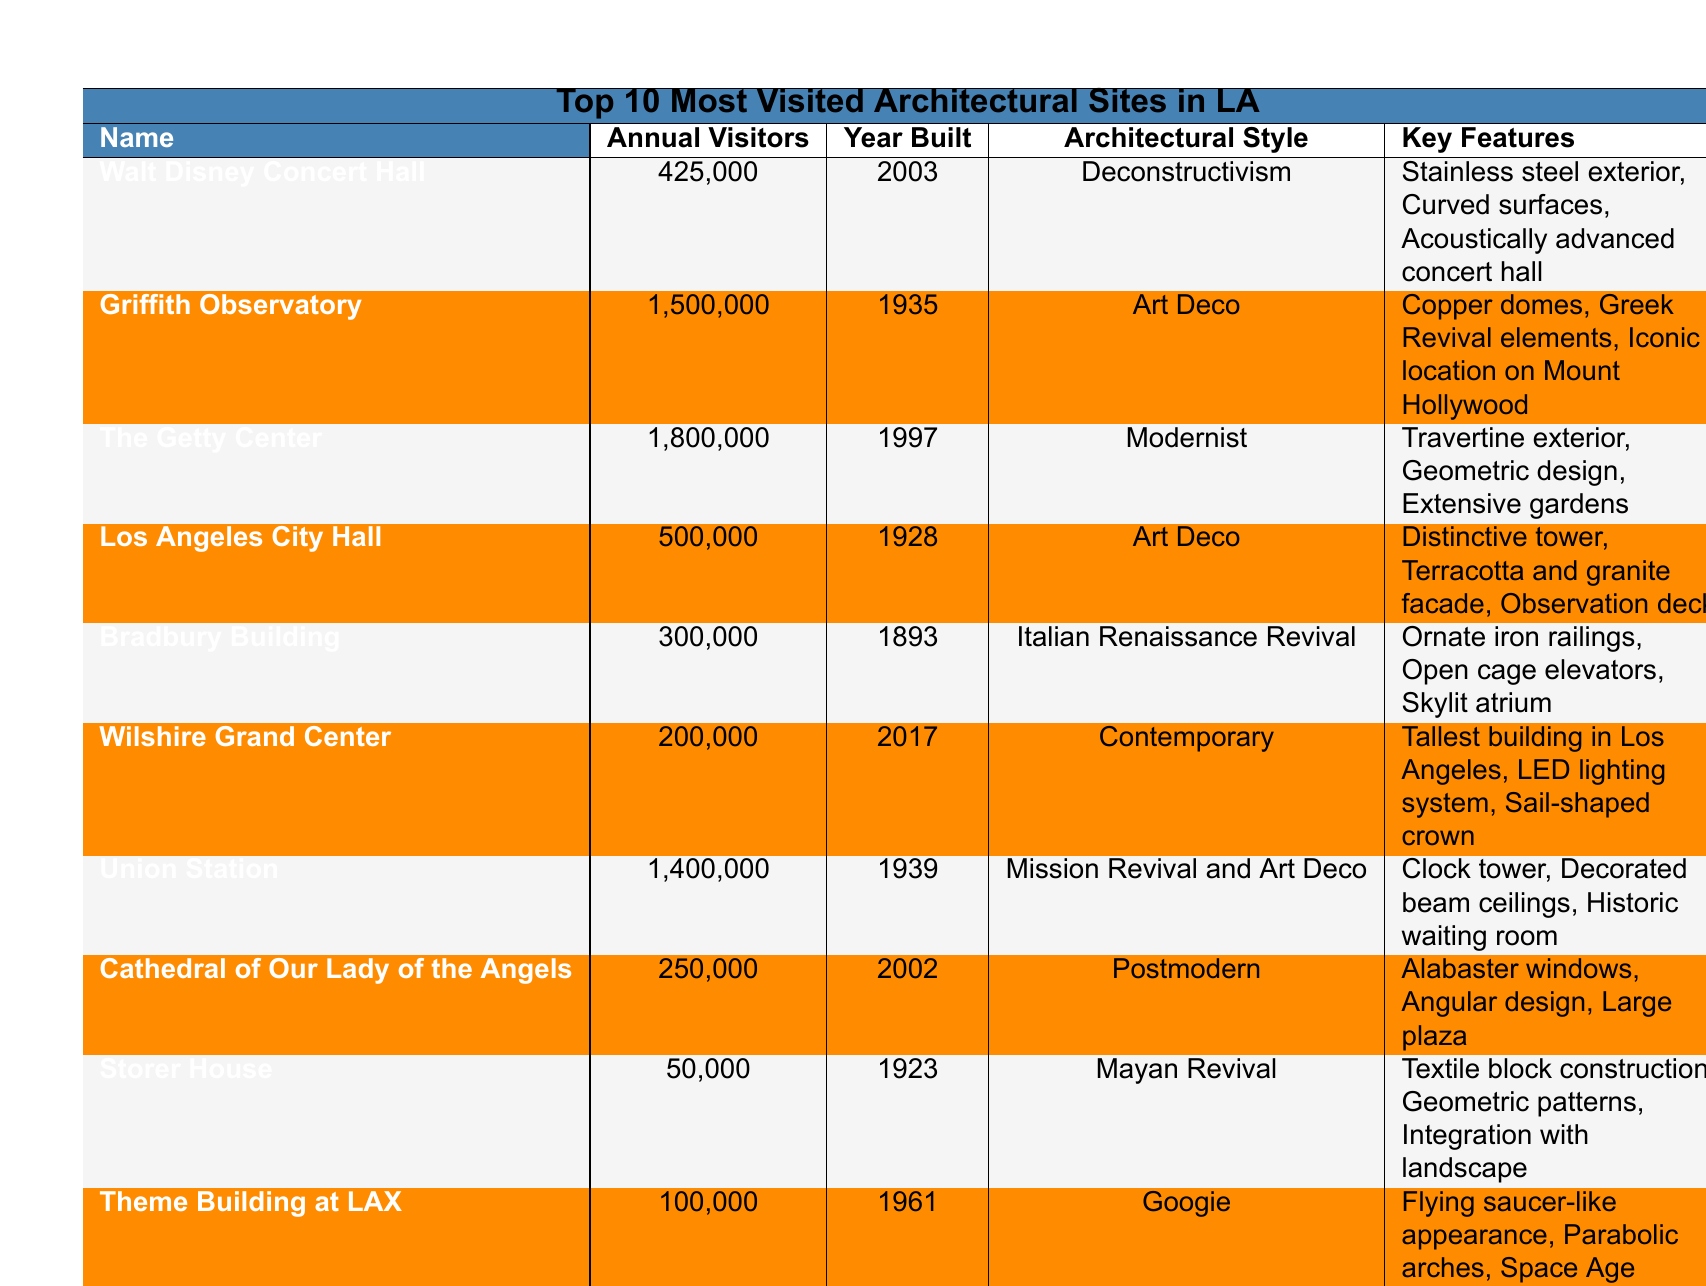What is the architectural style of the Griffith Observatory? The architectural style for the Griffith Observatory is listed in the table as Art Deco.
Answer: Art Deco Which site has the highest annual visitor count? Looking at the annual visitor counts, The Getty Center has the highest number with 1,800,000 visitors.
Answer: The Getty Center How many visitors does the Walt Disney Concert Hall attract annually? The annual visitor count for the Walt Disney Concert Hall is provided in the table as 425,000.
Answer: 425,000 What year was the Los Angeles City Hall built? The table indicates that the Los Angeles City Hall was built in the year 1928.
Answer: 1928 Which architectural styles are featured in the Wilshire Grand Center and the Cathedral of Our Lady of the Angels? The Wilshire Grand Center is classified as Contemporary, while the Cathedral of Our Lady of the Angels is Postmodern.
Answer: Contemporary and Postmodern Is the Storer House more or less visited than the Bradbury Building? The Storer House has 50,000 visitors, while the Bradbury Building has 300,000 visitors, so it is less visited.
Answer: Less visited What are the key features of the Union Station? The table lists the key features of Union Station as a clock tower, decorated beam ceilings, and a historic waiting room.
Answer: Clock tower, decorated beam ceilings, historic waiting room Which sites were built before 1950, and how many of them had over 1 million visitors? The sites built before 1950 are Griffith Observatory, Los Angeles City Hall, Bradbury Building, and Union Station. Out of these, 2 sites, Griffith Observatory (1,500,000) and Union Station (1,400,000), had over 1 million visitors.
Answer: 2 sites Calculate the average annual visitors for the top 3 most visited sites. The visitor counts for the top 3 sites are 1,800,000 (The Getty Center), 1,500,000 (Griffith Observatory), and 1,400,000 (Union Station). Summing these gives 1,800,000 + 1,500,000 + 1,400,000 = 4,700,000. There are 3 sites, so the average is 4,700,000 / 3 = 1,566,667.
Answer: 1,566,667 How does the architectural style of the Theme Building at LAX compare to that of the Cathedral of Our Lady of the Angels? The Theme Building at LAX has a Googie architectural style, while the Cathedral of Our Lady of the Angels has a Postmodern style. These styles represent different design philosophies and periods.
Answer: Different styles: Googie vs. Postmodern Which building is the tallest in Los Angeles and what unique feature does it have? The Wilshire Grand Center is the tallest building in Los Angeles, and it has a unique LED lighting system.
Answer: Wilshire Grand Center; LED lighting system 